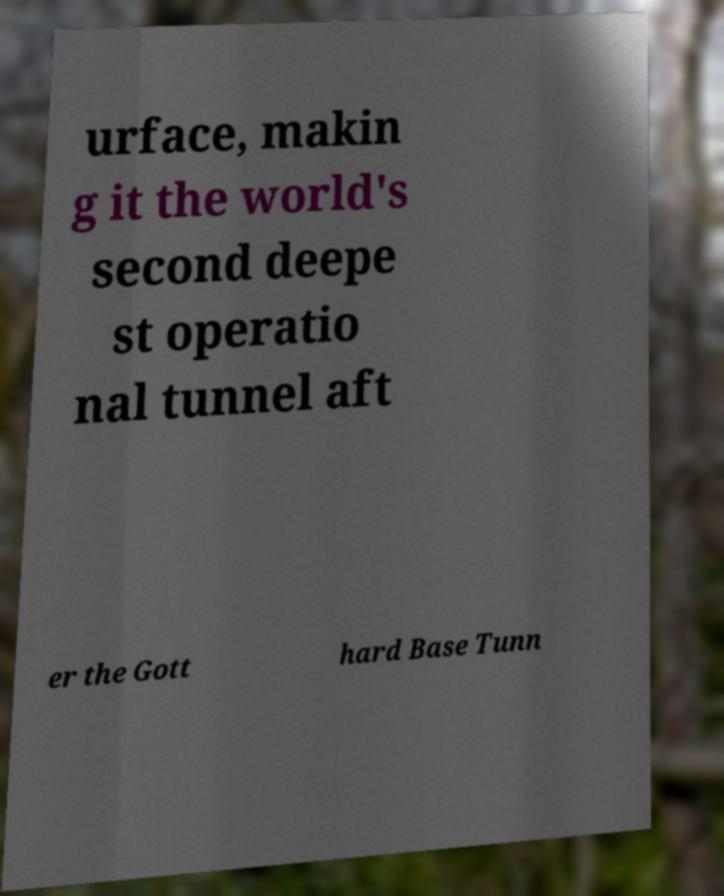Please identify and transcribe the text found in this image. urface, makin g it the world's second deepe st operatio nal tunnel aft er the Gott hard Base Tunn 